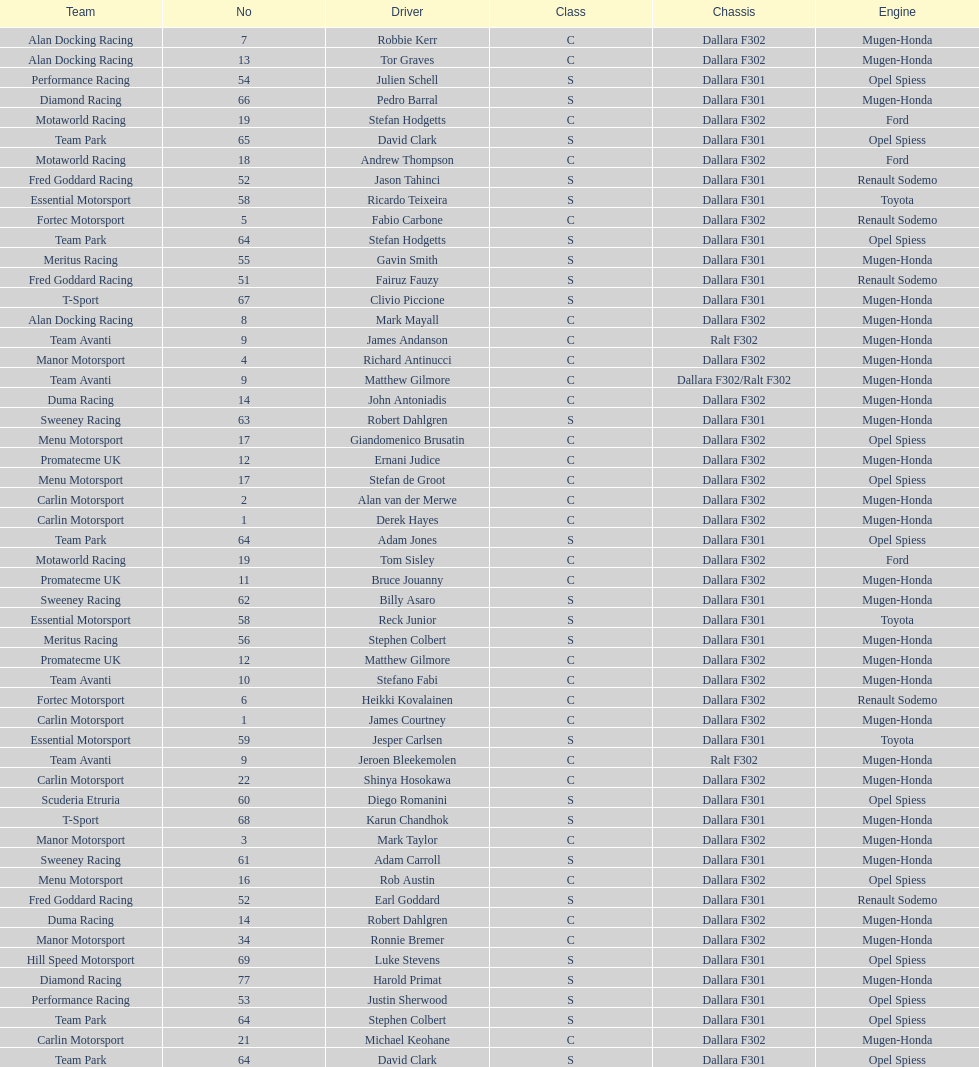Which engine was used the most by teams this season? Mugen-Honda. 